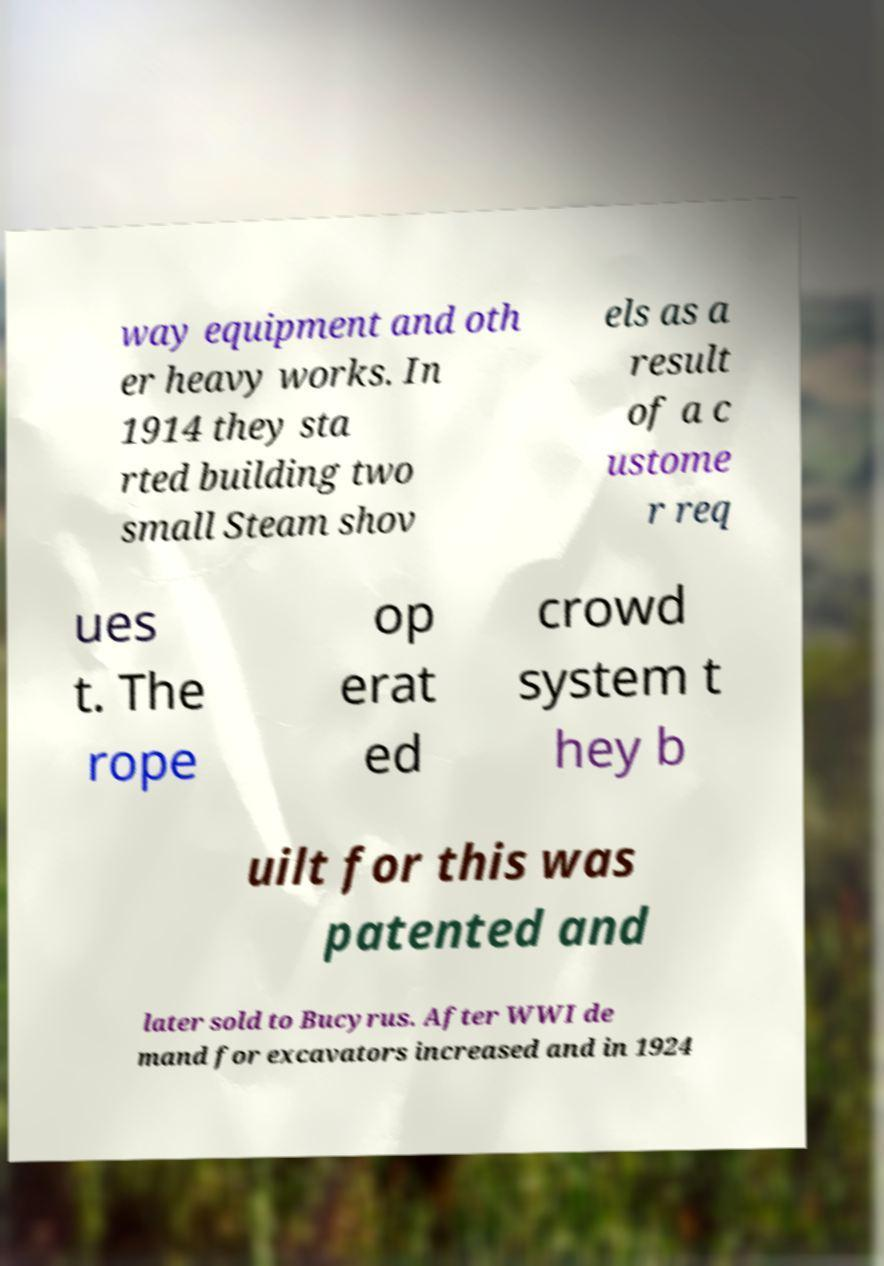For documentation purposes, I need the text within this image transcribed. Could you provide that? way equipment and oth er heavy works. In 1914 they sta rted building two small Steam shov els as a result of a c ustome r req ues t. The rope op erat ed crowd system t hey b uilt for this was patented and later sold to Bucyrus. After WWI de mand for excavators increased and in 1924 